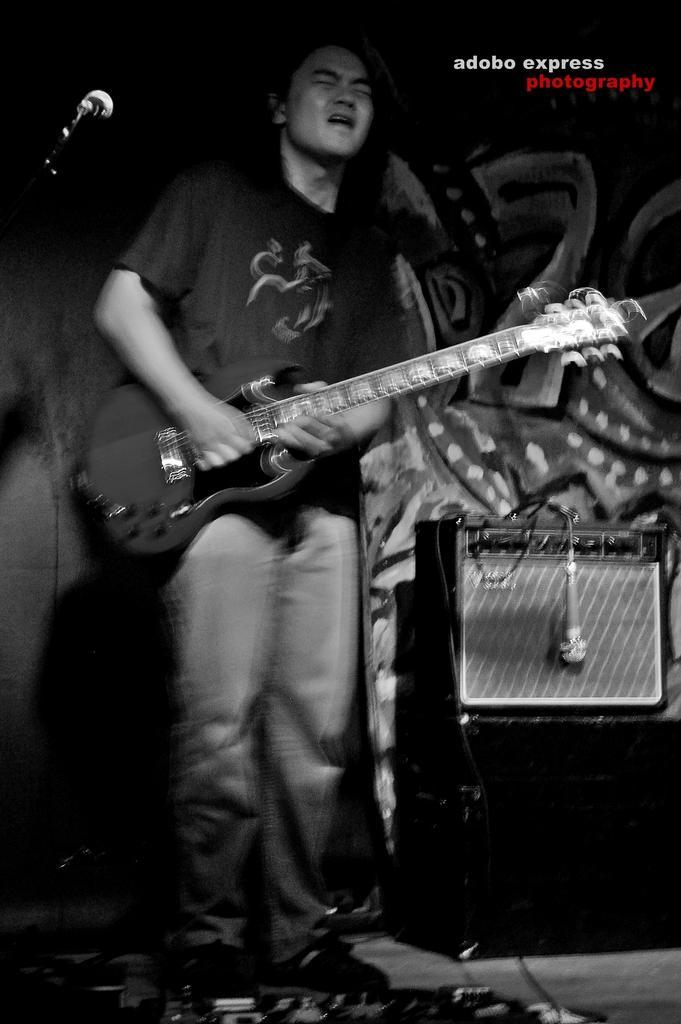Please provide a concise description of this image. This is of a black and white image. The man is standing and playing guitar. Here is the mike hanging. I think this is a speaker placed at the right corner of the image. 